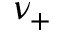Convert formula to latex. <formula><loc_0><loc_0><loc_500><loc_500>\nu _ { + }</formula> 